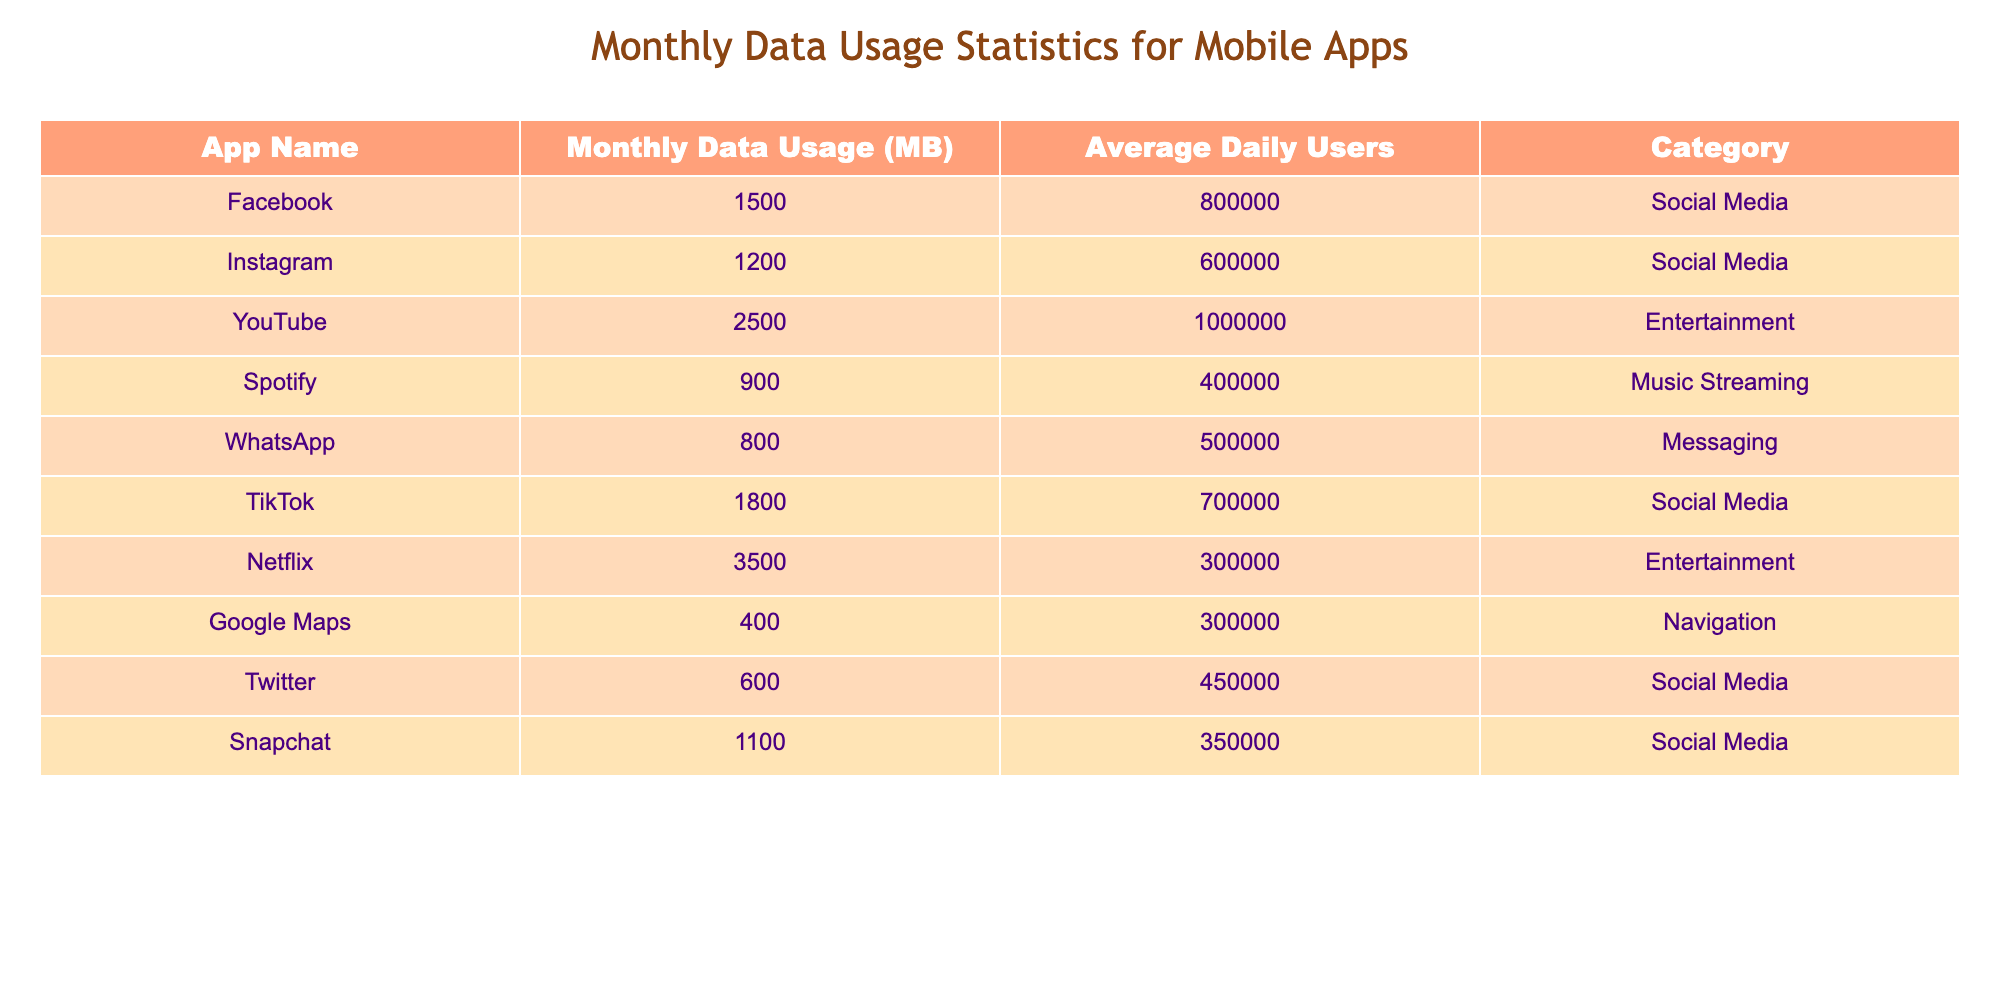What's the monthly data usage for Instagram? You can find Instagram's monthly data usage directly in the table under the "Monthly Data Usage (MB)" column, where the corresponding row is for Instagram. The value listed is 1200 MB.
Answer: 1200 MB How many average daily users does Netflix have? The average daily users for Netflix can be located in the table under the "Average Daily Users" column. The number listed next to Netflix is 300,000.
Answer: 300000 Is TikTok's data usage higher than WhatsApp's? By comparing the monthly data usage values for TikTok (1800 MB) and WhatsApp (800 MB) in the "Monthly Data Usage (MB)" column of the table, we see that 1800 is greater than 800, confirming that TikTok uses more data than WhatsApp.
Answer: Yes What is the total monthly data usage for all Social Media apps? To find the total monthly data usage for Social Media apps, sum the data usage values for Facebook (1500 MB), Instagram (1200 MB), TikTok (1800 MB), and Twitter (600 MB). The calculation is 1500 + 1200 + 1800 + 600 = 4100 MB.
Answer: 4100 MB Which category has the highest average daily users? To determine the highest average daily users by category, we analyze the "Average Daily Users" column by category. Entertainment has 1,000,000 users (YouTube) and 300,000 users (Netflix), while Social Media categories average to a higher total. Since the actual average is 800,000 (Facebook) & 700,000 (TikTok), it confirms that Entertainment (with a separate entry for YouTube) has the highest single-day user count.
Answer: Entertainment How many more MB does YouTube use than Spotify? By looking at the "Monthly Data Usage (MB)" for YouTube (2500 MB) and Spotify (900 MB), we subtract Spotify's value from YouTube's: 2500 - 900 = 1600 MB.
Answer: 1600 MB Is the average data usage for all apps more than 1000 MB? First, we sum the monthly data usage for all apps: 1500 + 1200 + 2500 + 900 + 800 + 1800 + 3500 + 400 + 600 + 1100 = 12200 MB. Then, we divide by the number of apps (10): 12200 / 10 = 1220 MB, which is greater than 1000 MB.
Answer: Yes What is the difference in average daily users between Facebook and Snapchat? The average daily users for Facebook is 800,000 and for Snapchat is 350,000. To find the difference, we subtract Snapchat's users from Facebook's: 800000 - 350000 = 450000.
Answer: 450000 